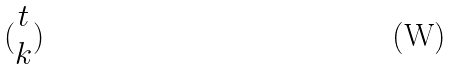Convert formula to latex. <formula><loc_0><loc_0><loc_500><loc_500>( \begin{matrix} t \\ k \end{matrix} )</formula> 